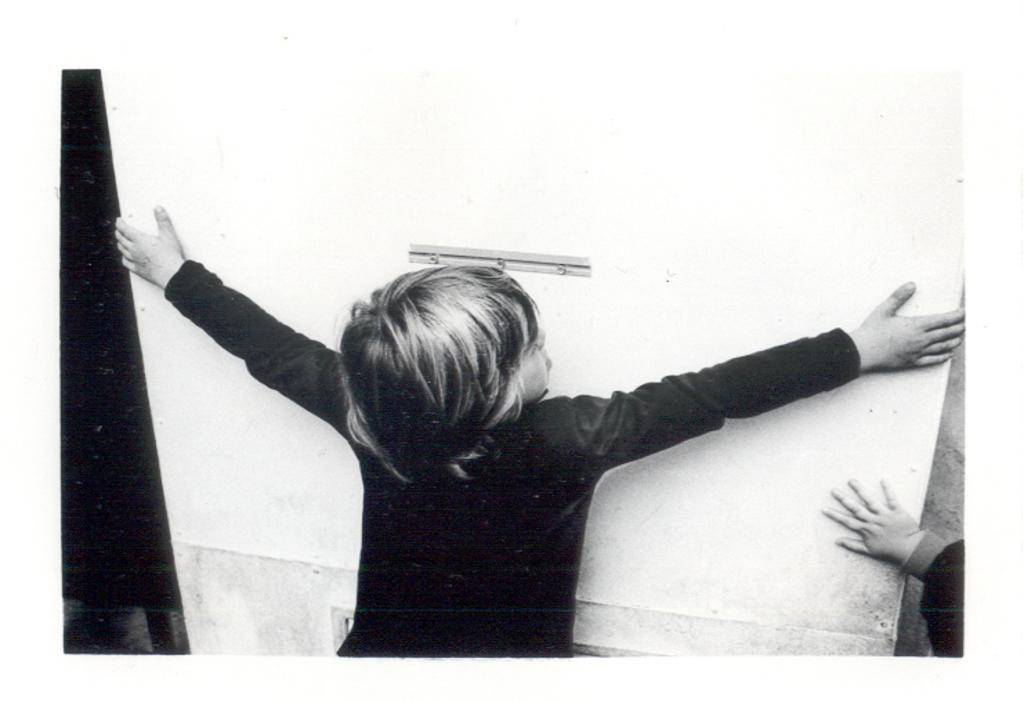What is the person in the image holding? There is a person holding an object in the image. Can you describe the interaction between the two people in the image? The other person has their hand on the object. What is the color scheme of the image? The image is in black and white. What type of news is being reported by the person holding the object in the image? There is no news being reported in the image, as it does not contain any text or visual cues suggesting a news event. 